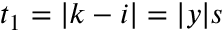Convert formula to latex. <formula><loc_0><loc_0><loc_500><loc_500>t _ { 1 } = | k - i | = | y | s</formula> 